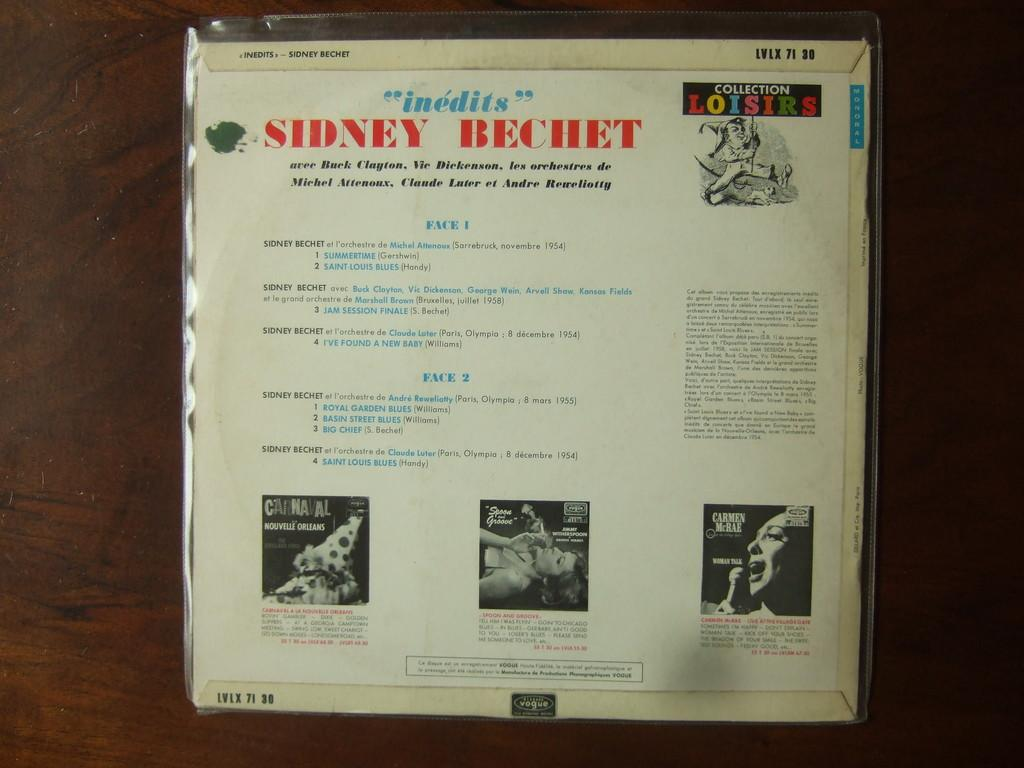<image>
Write a terse but informative summary of the picture. A record cover of Sidney Bechet labeled Inedits with different songs labeled. 